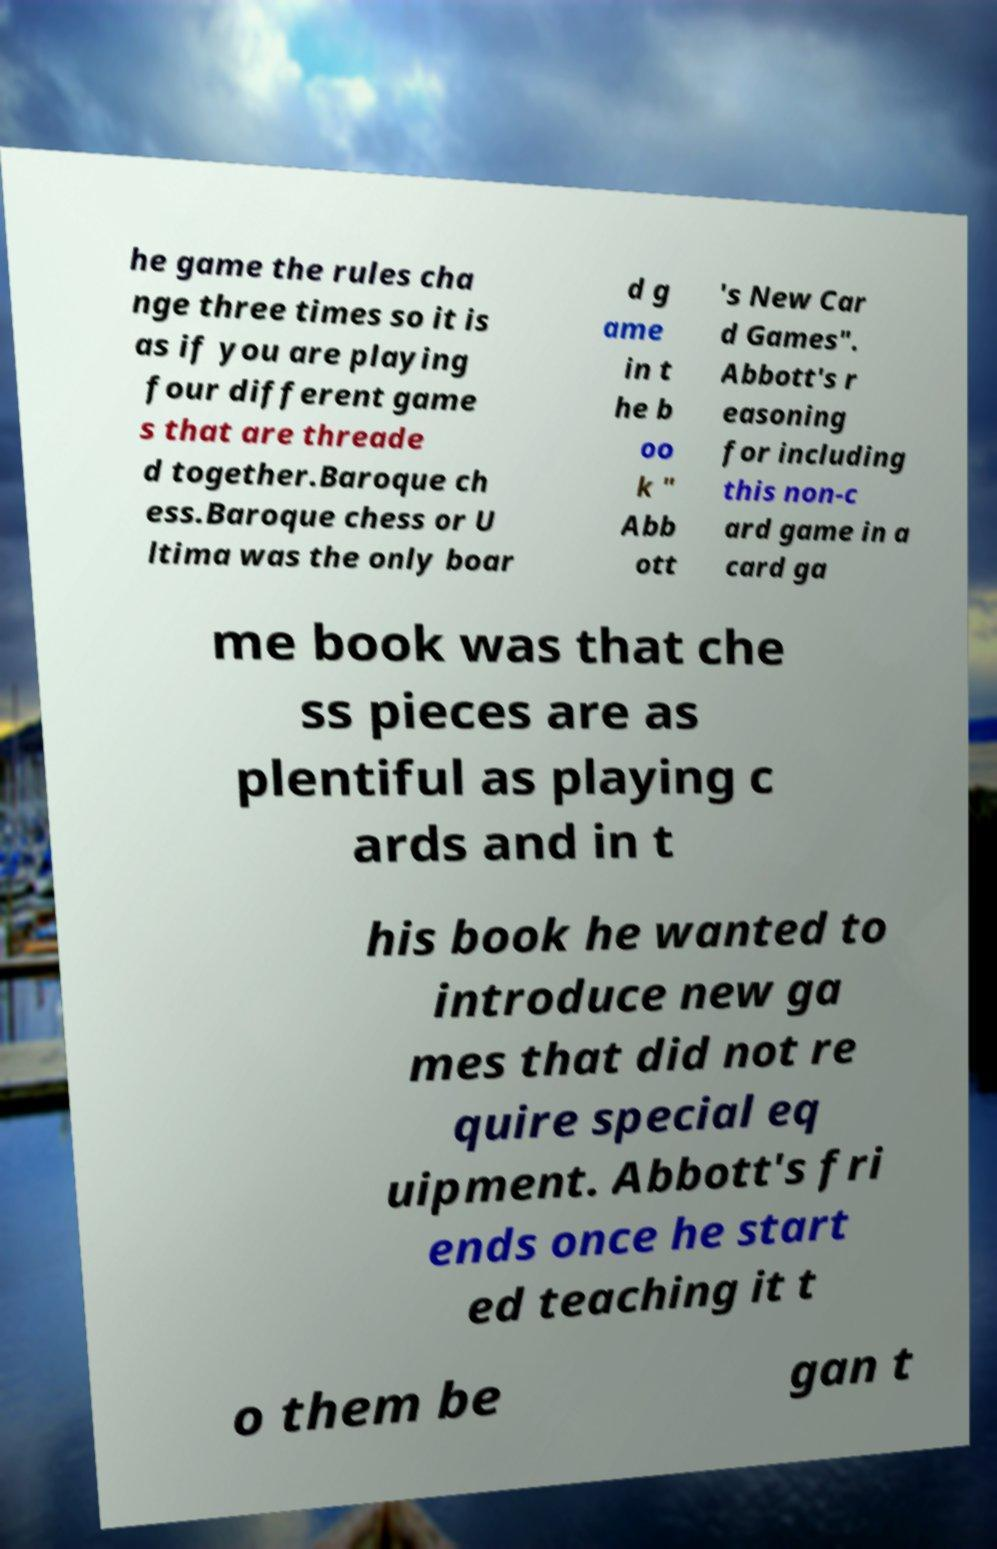Can you accurately transcribe the text from the provided image for me? he game the rules cha nge three times so it is as if you are playing four different game s that are threade d together.Baroque ch ess.Baroque chess or U ltima was the only boar d g ame in t he b oo k " Abb ott 's New Car d Games". Abbott's r easoning for including this non-c ard game in a card ga me book was that che ss pieces are as plentiful as playing c ards and in t his book he wanted to introduce new ga mes that did not re quire special eq uipment. Abbott's fri ends once he start ed teaching it t o them be gan t 